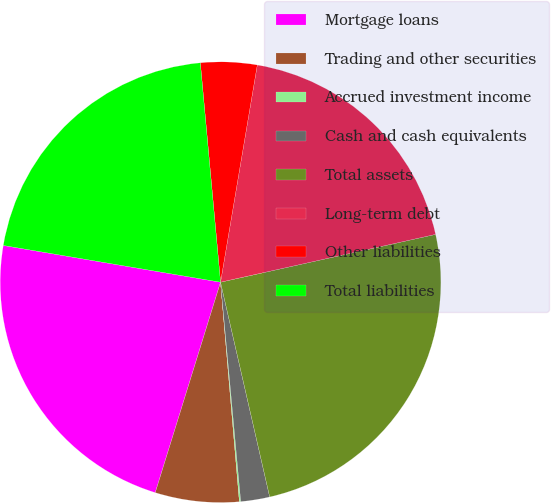Convert chart. <chart><loc_0><loc_0><loc_500><loc_500><pie_chart><fcel>Mortgage loans<fcel>Trading and other securities<fcel>Accrued investment income<fcel>Cash and cash equivalents<fcel>Total assets<fcel>Long-term debt<fcel>Other liabilities<fcel>Total liabilities<nl><fcel>22.88%<fcel>6.15%<fcel>0.1%<fcel>2.12%<fcel>24.9%<fcel>18.85%<fcel>4.13%<fcel>20.87%<nl></chart> 